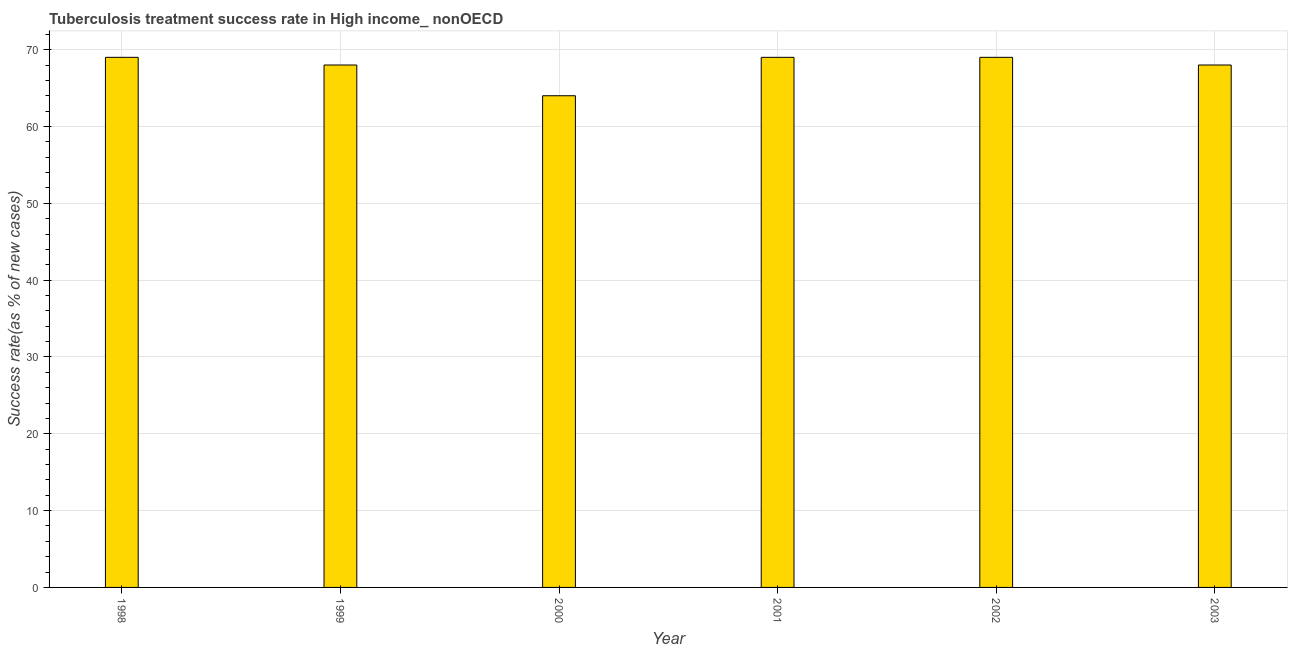Does the graph contain any zero values?
Your response must be concise. No. What is the title of the graph?
Your answer should be very brief. Tuberculosis treatment success rate in High income_ nonOECD. What is the label or title of the Y-axis?
Make the answer very short. Success rate(as % of new cases). Across all years, what is the minimum tuberculosis treatment success rate?
Give a very brief answer. 64. In which year was the tuberculosis treatment success rate maximum?
Provide a short and direct response. 1998. In which year was the tuberculosis treatment success rate minimum?
Ensure brevity in your answer.  2000. What is the sum of the tuberculosis treatment success rate?
Your answer should be very brief. 407. What is the difference between the tuberculosis treatment success rate in 1998 and 2001?
Make the answer very short. 0. What is the median tuberculosis treatment success rate?
Provide a succinct answer. 68.5. In how many years, is the tuberculosis treatment success rate greater than 4 %?
Offer a very short reply. 6. Do a majority of the years between 1999 and 2000 (inclusive) have tuberculosis treatment success rate greater than 56 %?
Your answer should be very brief. Yes. What is the ratio of the tuberculosis treatment success rate in 2002 to that in 2003?
Provide a succinct answer. 1.01. Is the difference between the tuberculosis treatment success rate in 1999 and 2002 greater than the difference between any two years?
Provide a succinct answer. No. What is the difference between the highest and the second highest tuberculosis treatment success rate?
Give a very brief answer. 0. Is the sum of the tuberculosis treatment success rate in 1999 and 2000 greater than the maximum tuberculosis treatment success rate across all years?
Provide a succinct answer. Yes. In how many years, is the tuberculosis treatment success rate greater than the average tuberculosis treatment success rate taken over all years?
Provide a short and direct response. 5. What is the Success rate(as % of new cases) in 1999?
Offer a terse response. 68. What is the Success rate(as % of new cases) of 2000?
Provide a short and direct response. 64. What is the Success rate(as % of new cases) of 2002?
Provide a short and direct response. 69. What is the Success rate(as % of new cases) of 2003?
Provide a succinct answer. 68. What is the difference between the Success rate(as % of new cases) in 1998 and 1999?
Offer a terse response. 1. What is the difference between the Success rate(as % of new cases) in 1998 and 2000?
Ensure brevity in your answer.  5. What is the difference between the Success rate(as % of new cases) in 1998 and 2001?
Make the answer very short. 0. What is the difference between the Success rate(as % of new cases) in 1998 and 2003?
Give a very brief answer. 1. What is the difference between the Success rate(as % of new cases) in 1999 and 2001?
Keep it short and to the point. -1. What is the difference between the Success rate(as % of new cases) in 1999 and 2002?
Provide a succinct answer. -1. What is the difference between the Success rate(as % of new cases) in 1999 and 2003?
Make the answer very short. 0. What is the difference between the Success rate(as % of new cases) in 2000 and 2001?
Your response must be concise. -5. What is the ratio of the Success rate(as % of new cases) in 1998 to that in 2000?
Your answer should be compact. 1.08. What is the ratio of the Success rate(as % of new cases) in 1998 to that in 2001?
Give a very brief answer. 1. What is the ratio of the Success rate(as % of new cases) in 1998 to that in 2003?
Ensure brevity in your answer.  1.01. What is the ratio of the Success rate(as % of new cases) in 1999 to that in 2000?
Offer a very short reply. 1.06. What is the ratio of the Success rate(as % of new cases) in 1999 to that in 2002?
Your response must be concise. 0.99. What is the ratio of the Success rate(as % of new cases) in 2000 to that in 2001?
Your response must be concise. 0.93. What is the ratio of the Success rate(as % of new cases) in 2000 to that in 2002?
Offer a very short reply. 0.93. What is the ratio of the Success rate(as % of new cases) in 2000 to that in 2003?
Ensure brevity in your answer.  0.94. What is the ratio of the Success rate(as % of new cases) in 2001 to that in 2002?
Provide a succinct answer. 1. 